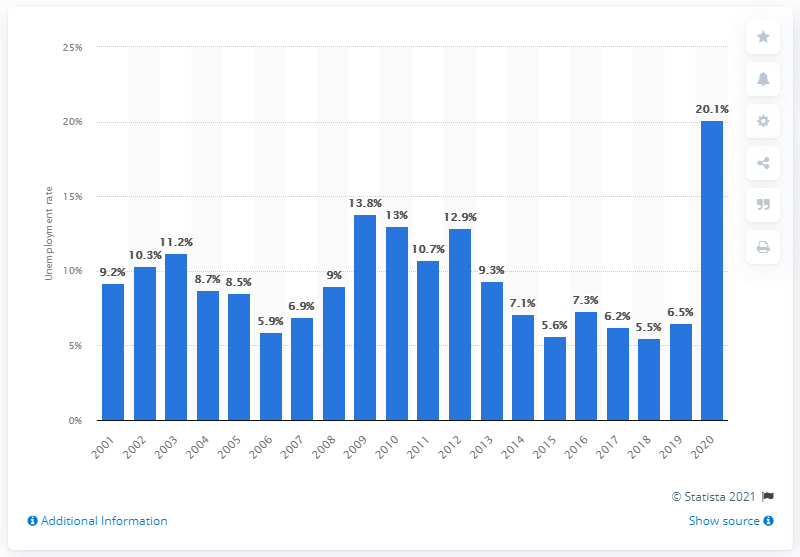Identify some key points in this picture. In 2020, approximately 20.1% of all private wage and salary workers in the U.S. motion picture and sound recording industry were unemployed. 